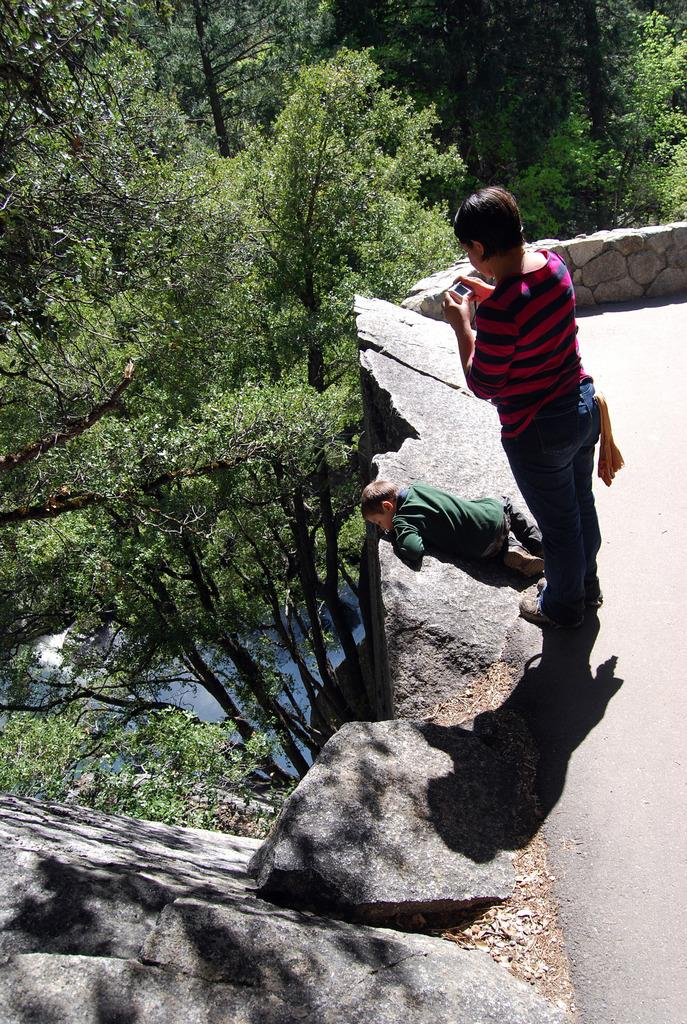What is the person in the image doing? The person is standing in the image and holding an object. Can you describe the child in the image? The child is lying on a rock in the image. What type of natural elements can be seen in the image? There are trees and rocks in the image. What type of alarm is going off in the image? There is no alarm present in the image. How many babies are visible in the image? There are no babies visible in the image; only a person and a child are present. 